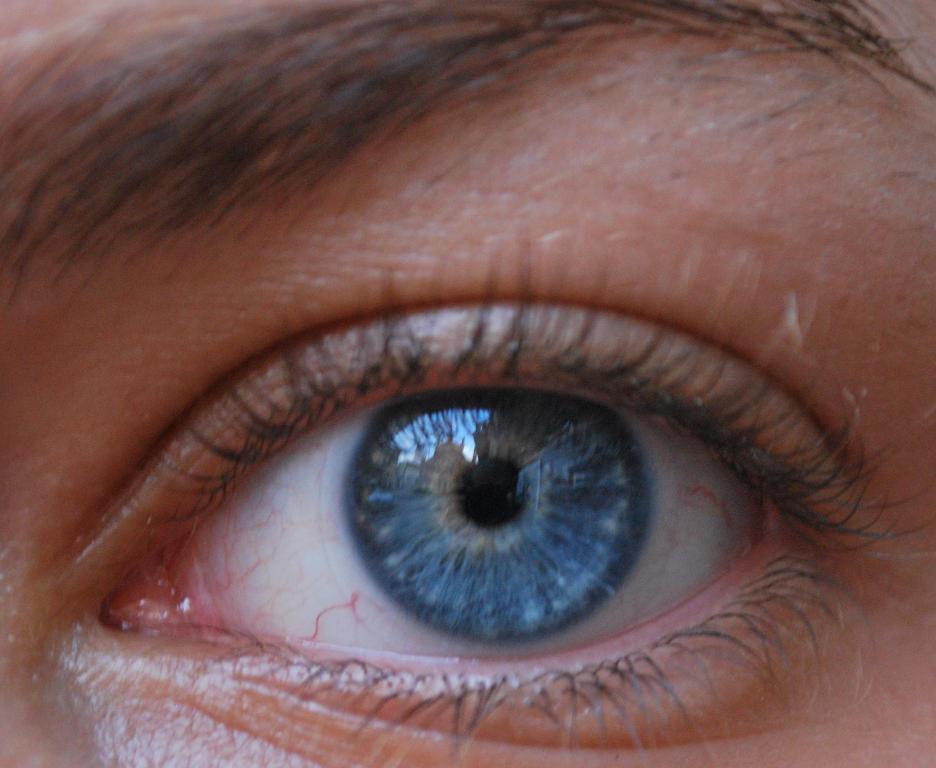What part of a person's face can be seen in the image? A person's eye and eyebrows are visible in the image. Can you describe the person's eye in the image? The person's eye is visible in the image, but no specific details about the eye can be determined from the provided facts. What type of collar is the person wearing in the image? There is no collar visible in the image, as only the person's eye and eyebrows are visible. How many circles can be seen in the image? There are no circles present in the image; only the person's eye and eyebrows are visible. 